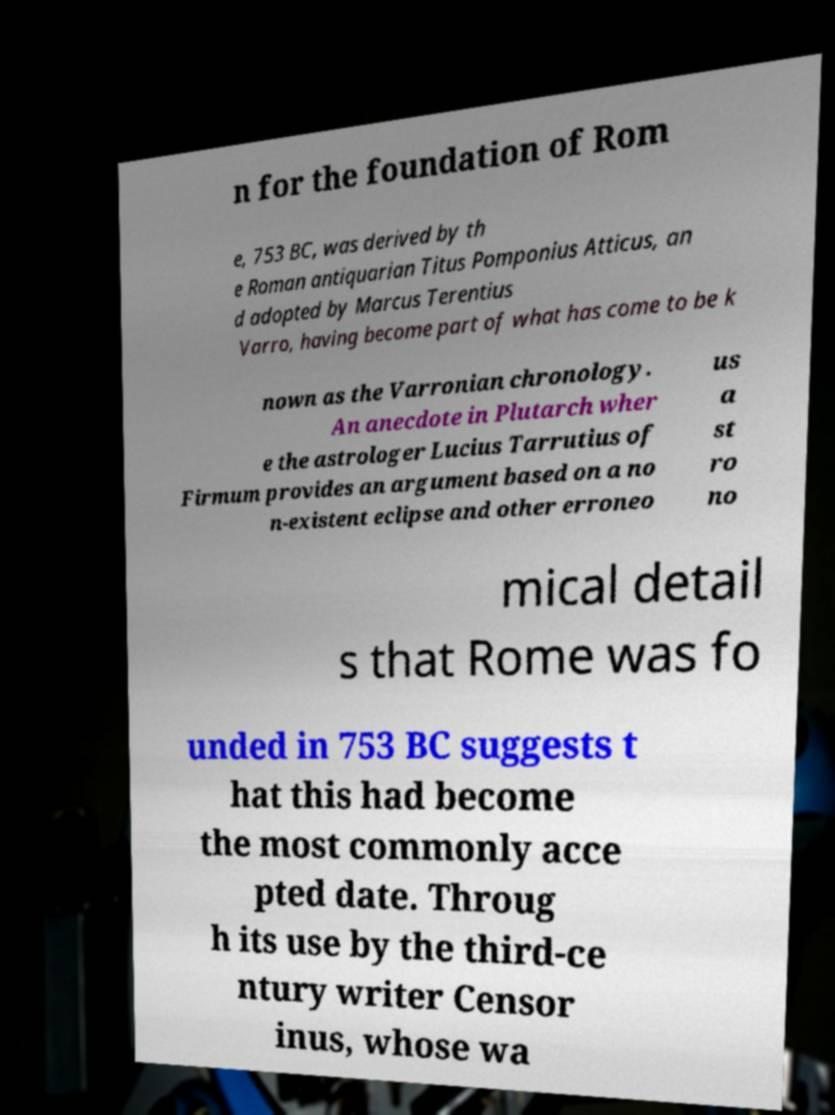Can you read and provide the text displayed in the image?This photo seems to have some interesting text. Can you extract and type it out for me? n for the foundation of Rom e, 753 BC, was derived by th e Roman antiquarian Titus Pomponius Atticus, an d adopted by Marcus Terentius Varro, having become part of what has come to be k nown as the Varronian chronology. An anecdote in Plutarch wher e the astrologer Lucius Tarrutius of Firmum provides an argument based on a no n-existent eclipse and other erroneo us a st ro no mical detail s that Rome was fo unded in 753 BC suggests t hat this had become the most commonly acce pted date. Throug h its use by the third-ce ntury writer Censor inus, whose wa 